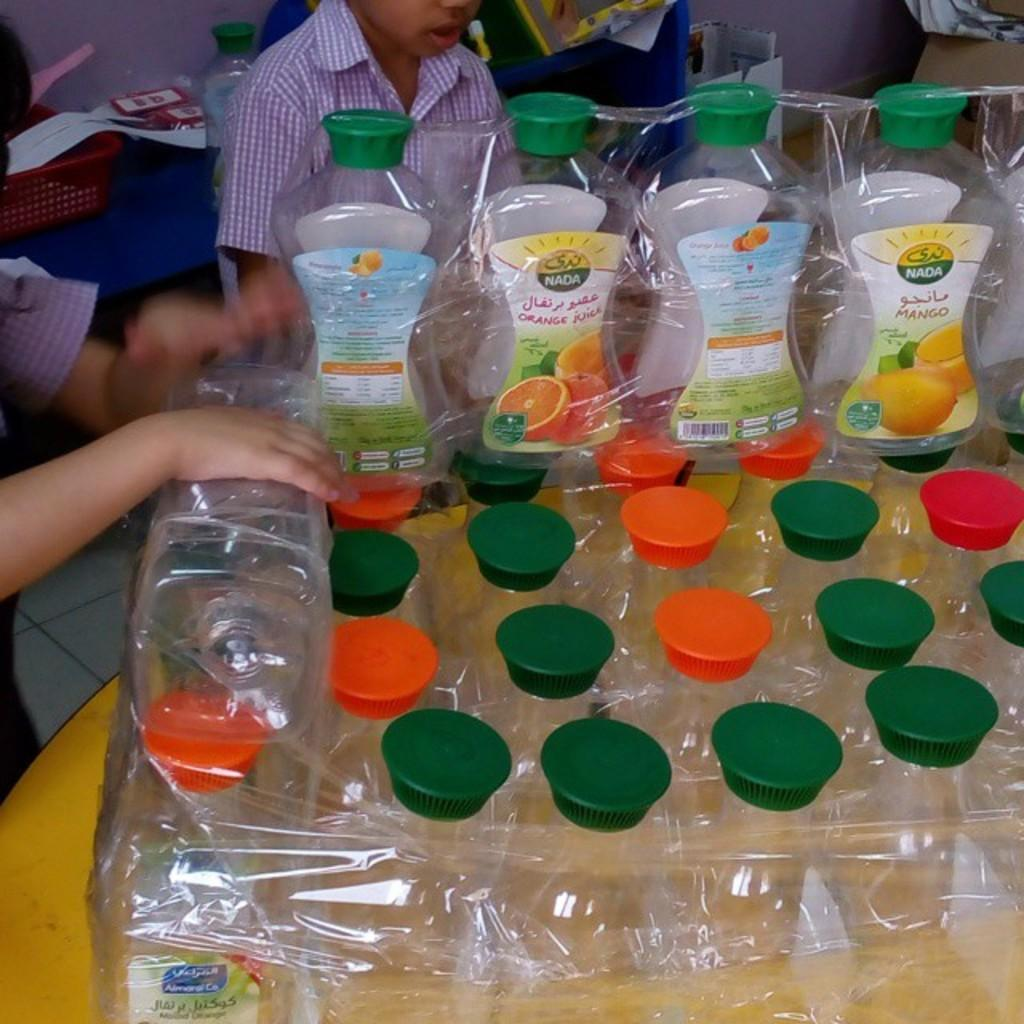Provide a one-sentence caption for the provided image. Empty bottles of NADA brand fruit juice are wrapped together. 